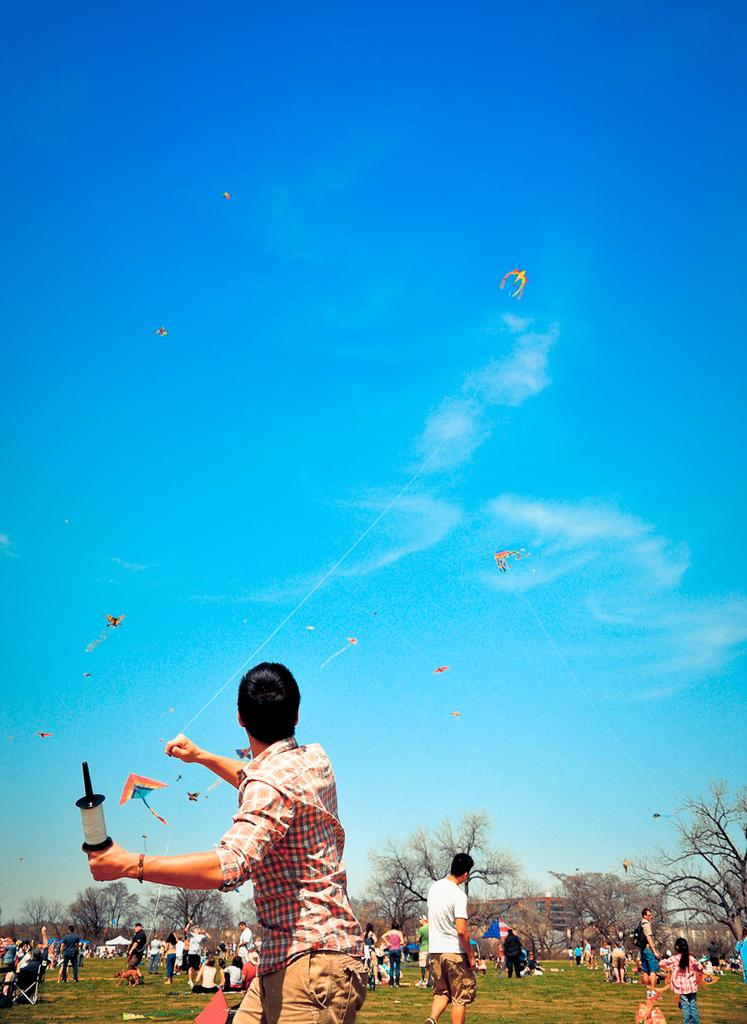What type of vegetation can be seen in the image? There is grass in the image. Who or what is present in the image? There are people in the image. What can be seen in the background of the image? There are trees and buildings in the background of the image. What is happening in the sky in the image? Kites are visible in the sky, and clouds are present. What type of sheet is being used to catch the kites in the image? There is no sheet present in the image; kites are simply visible in the sky. How many pails of water are being used by the people in the image? There is no mention of pails or water in the image; the focus is on the grass, people, background, and sky. 